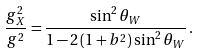Convert formula to latex. <formula><loc_0><loc_0><loc_500><loc_500>\frac { g _ { X } ^ { 2 } } { g ^ { 2 } } = \frac { \sin ^ { 2 } \theta _ { W } } { 1 - 2 \left ( 1 + b ^ { 2 } \right ) \sin ^ { 2 } \theta _ { W } } \, .</formula> 